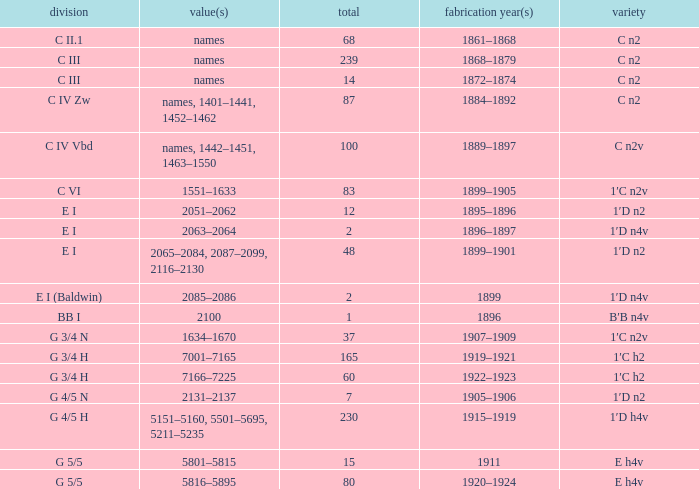Which Year(s) of Manufacture has a Quantity larger than 60, and a Number(s) of 7001–7165? 1919–1921. 